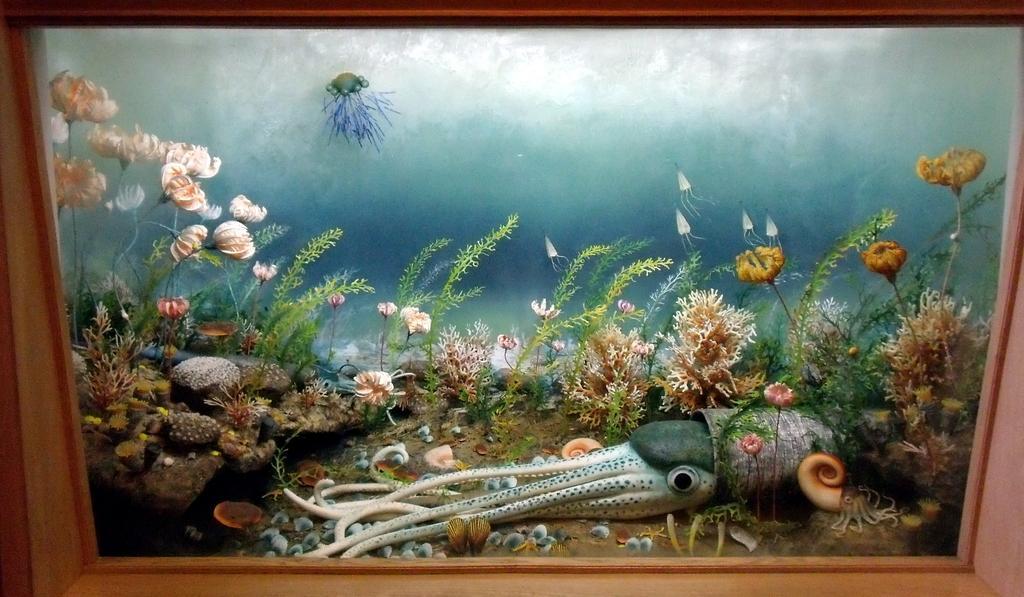Could you give a brief overview of what you see in this image? In the picture I can see the photo frame. In the photo frame I can see the underwater environment as I can see the plants, rocks and an octopus in the water. 